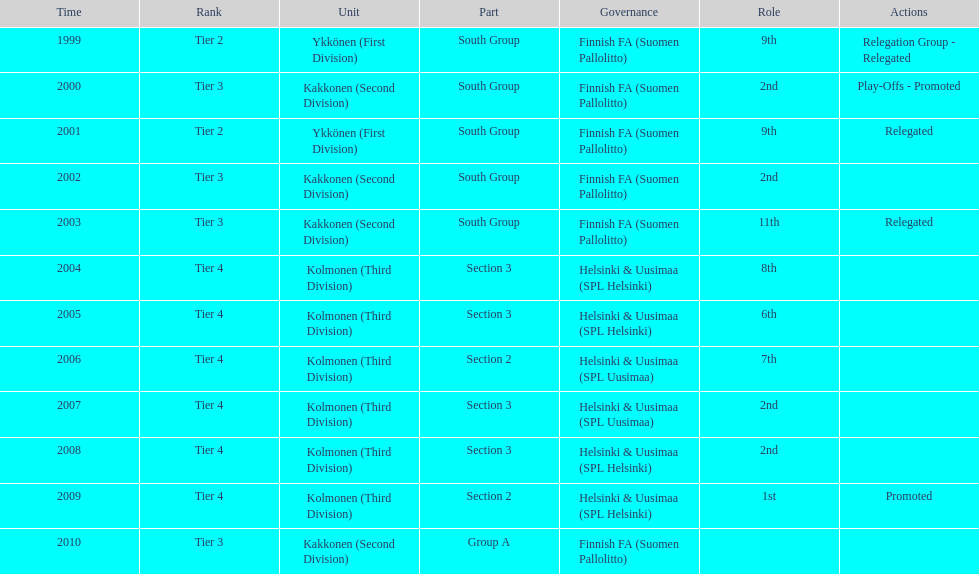Of the third division, how many were in section3? 4. 